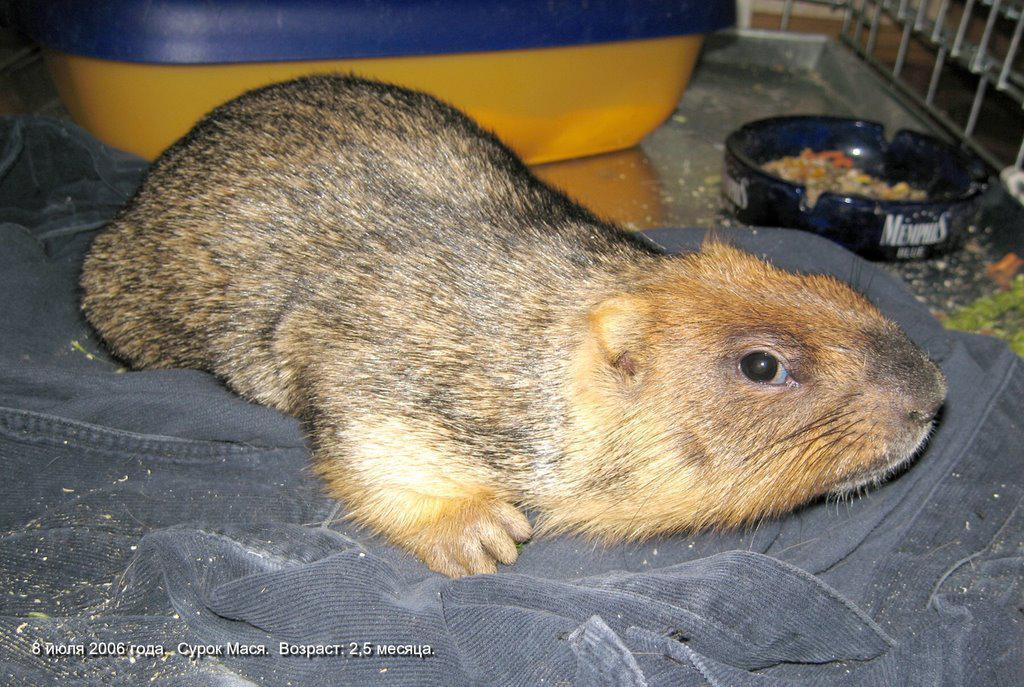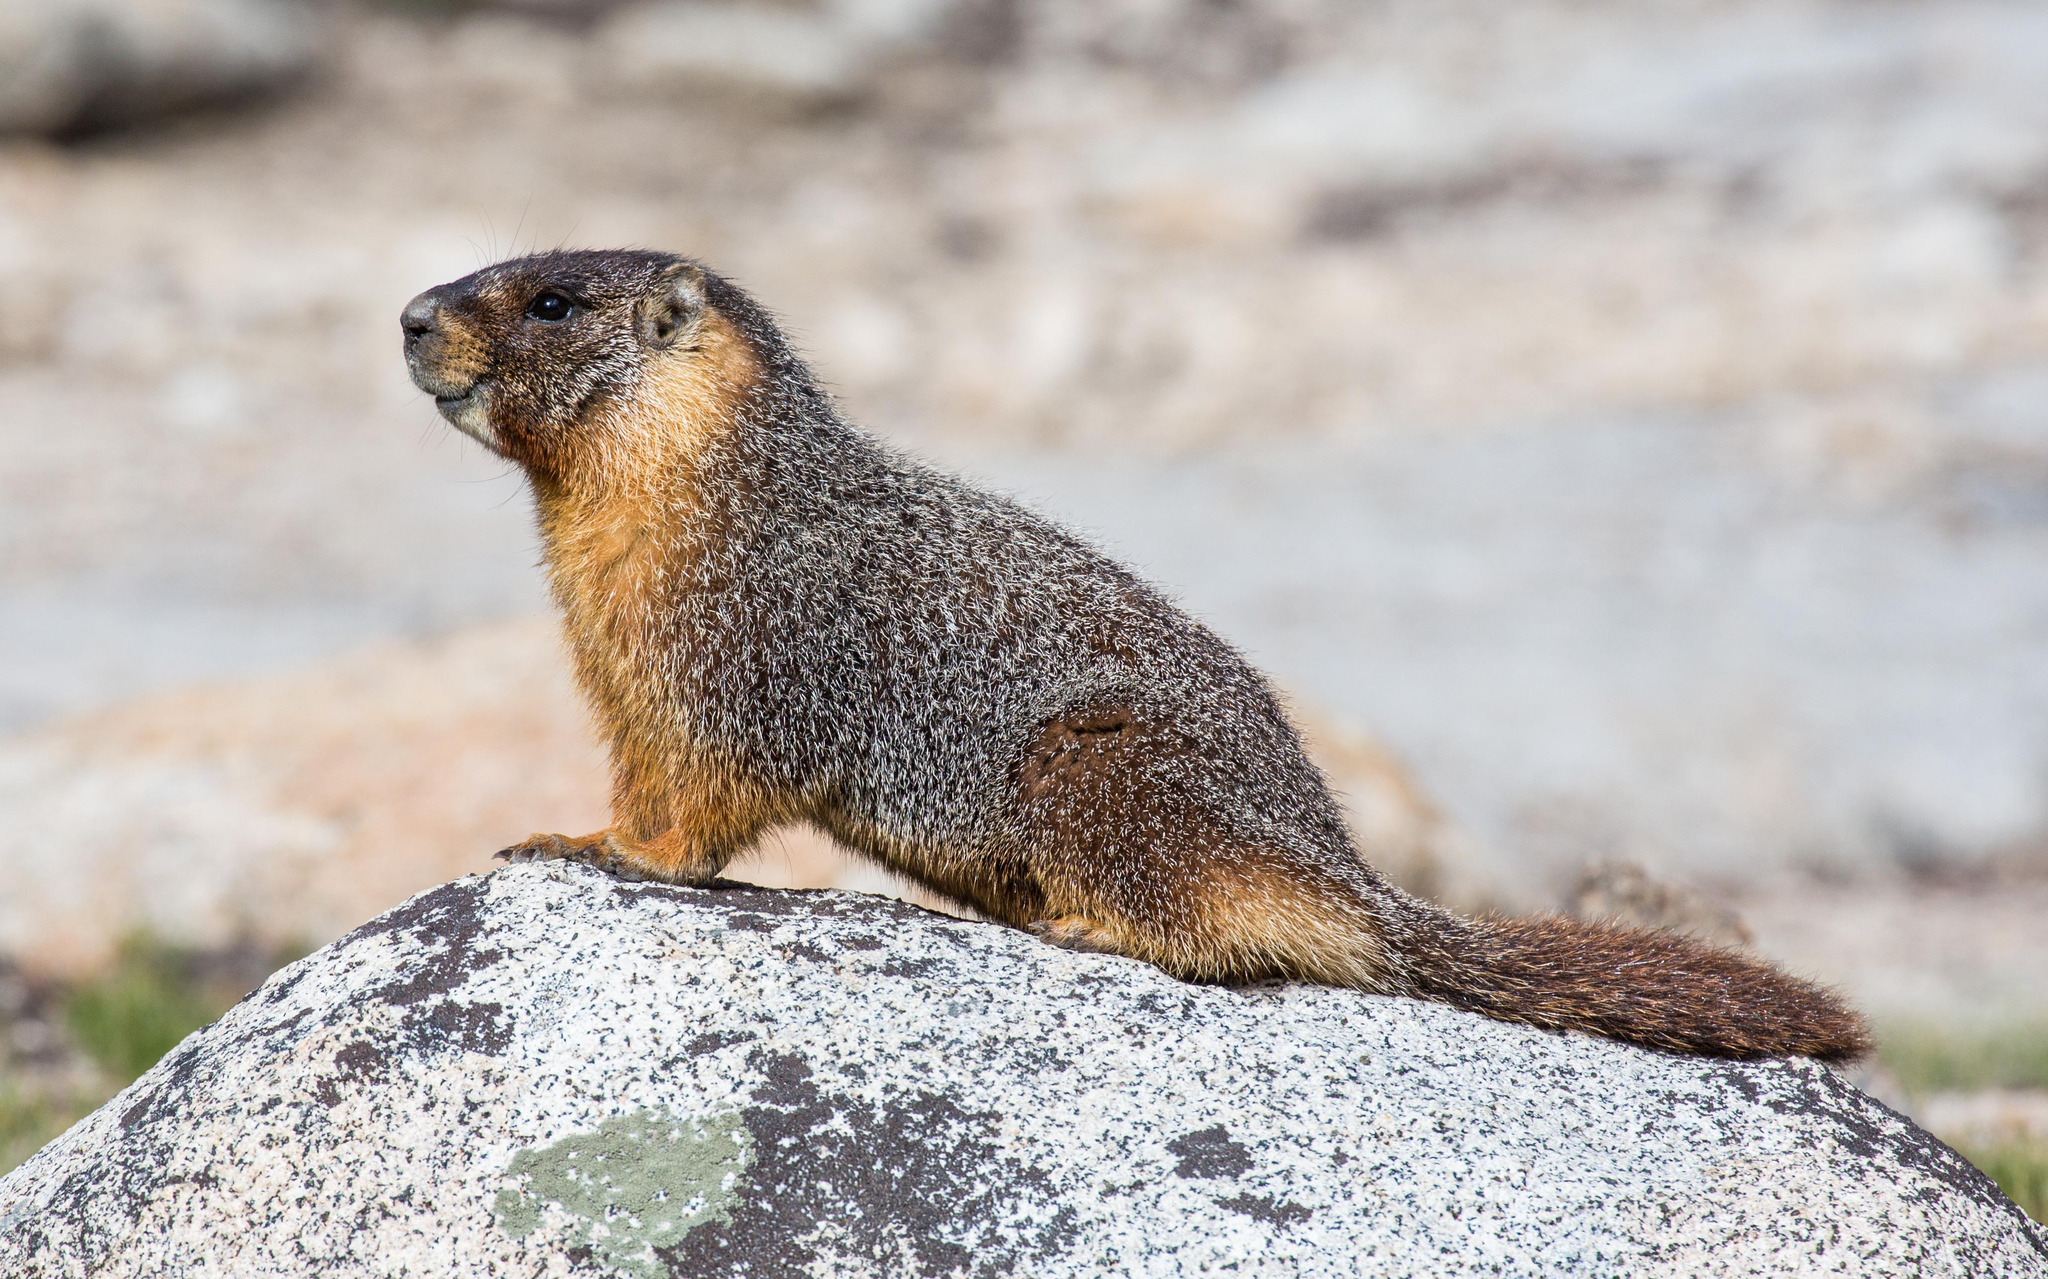The first image is the image on the left, the second image is the image on the right. For the images displayed, is the sentence "There is at least one animal standing on its hind legs holding something in its front paws." factually correct? Answer yes or no. No. The first image is the image on the left, the second image is the image on the right. Examine the images to the left and right. Is the description "An image contains at least twice as many marmots as the other image." accurate? Answer yes or no. No. 